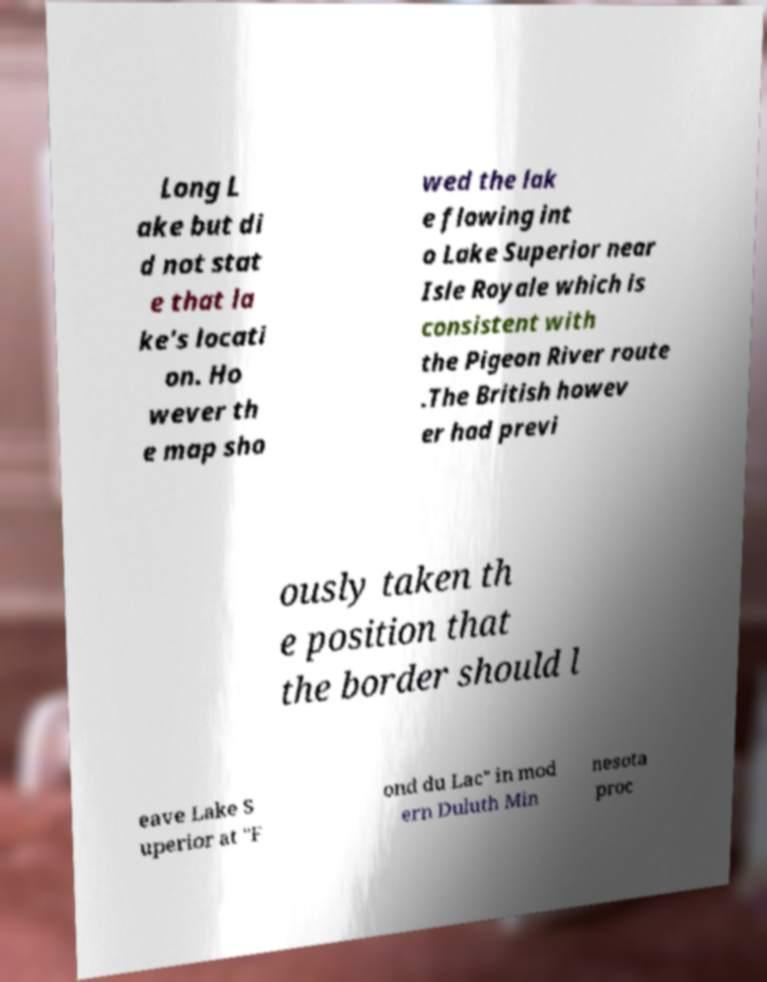Can you accurately transcribe the text from the provided image for me? Long L ake but di d not stat e that la ke's locati on. Ho wever th e map sho wed the lak e flowing int o Lake Superior near Isle Royale which is consistent with the Pigeon River route .The British howev er had previ ously taken th e position that the border should l eave Lake S uperior at "F ond du Lac" in mod ern Duluth Min nesota proc 